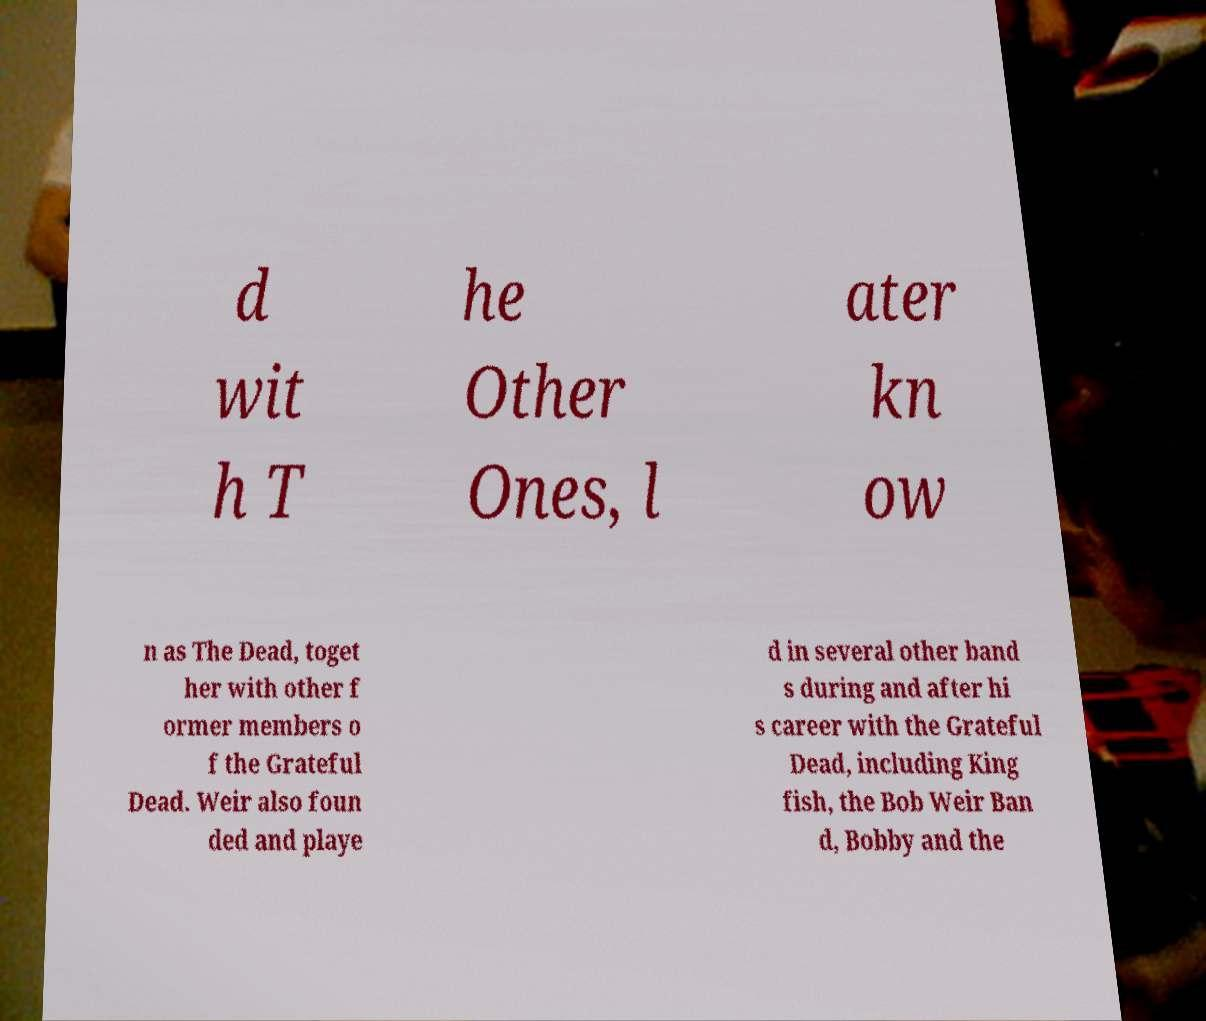Could you assist in decoding the text presented in this image and type it out clearly? d wit h T he Other Ones, l ater kn ow n as The Dead, toget her with other f ormer members o f the Grateful Dead. Weir also foun ded and playe d in several other band s during and after hi s career with the Grateful Dead, including King fish, the Bob Weir Ban d, Bobby and the 